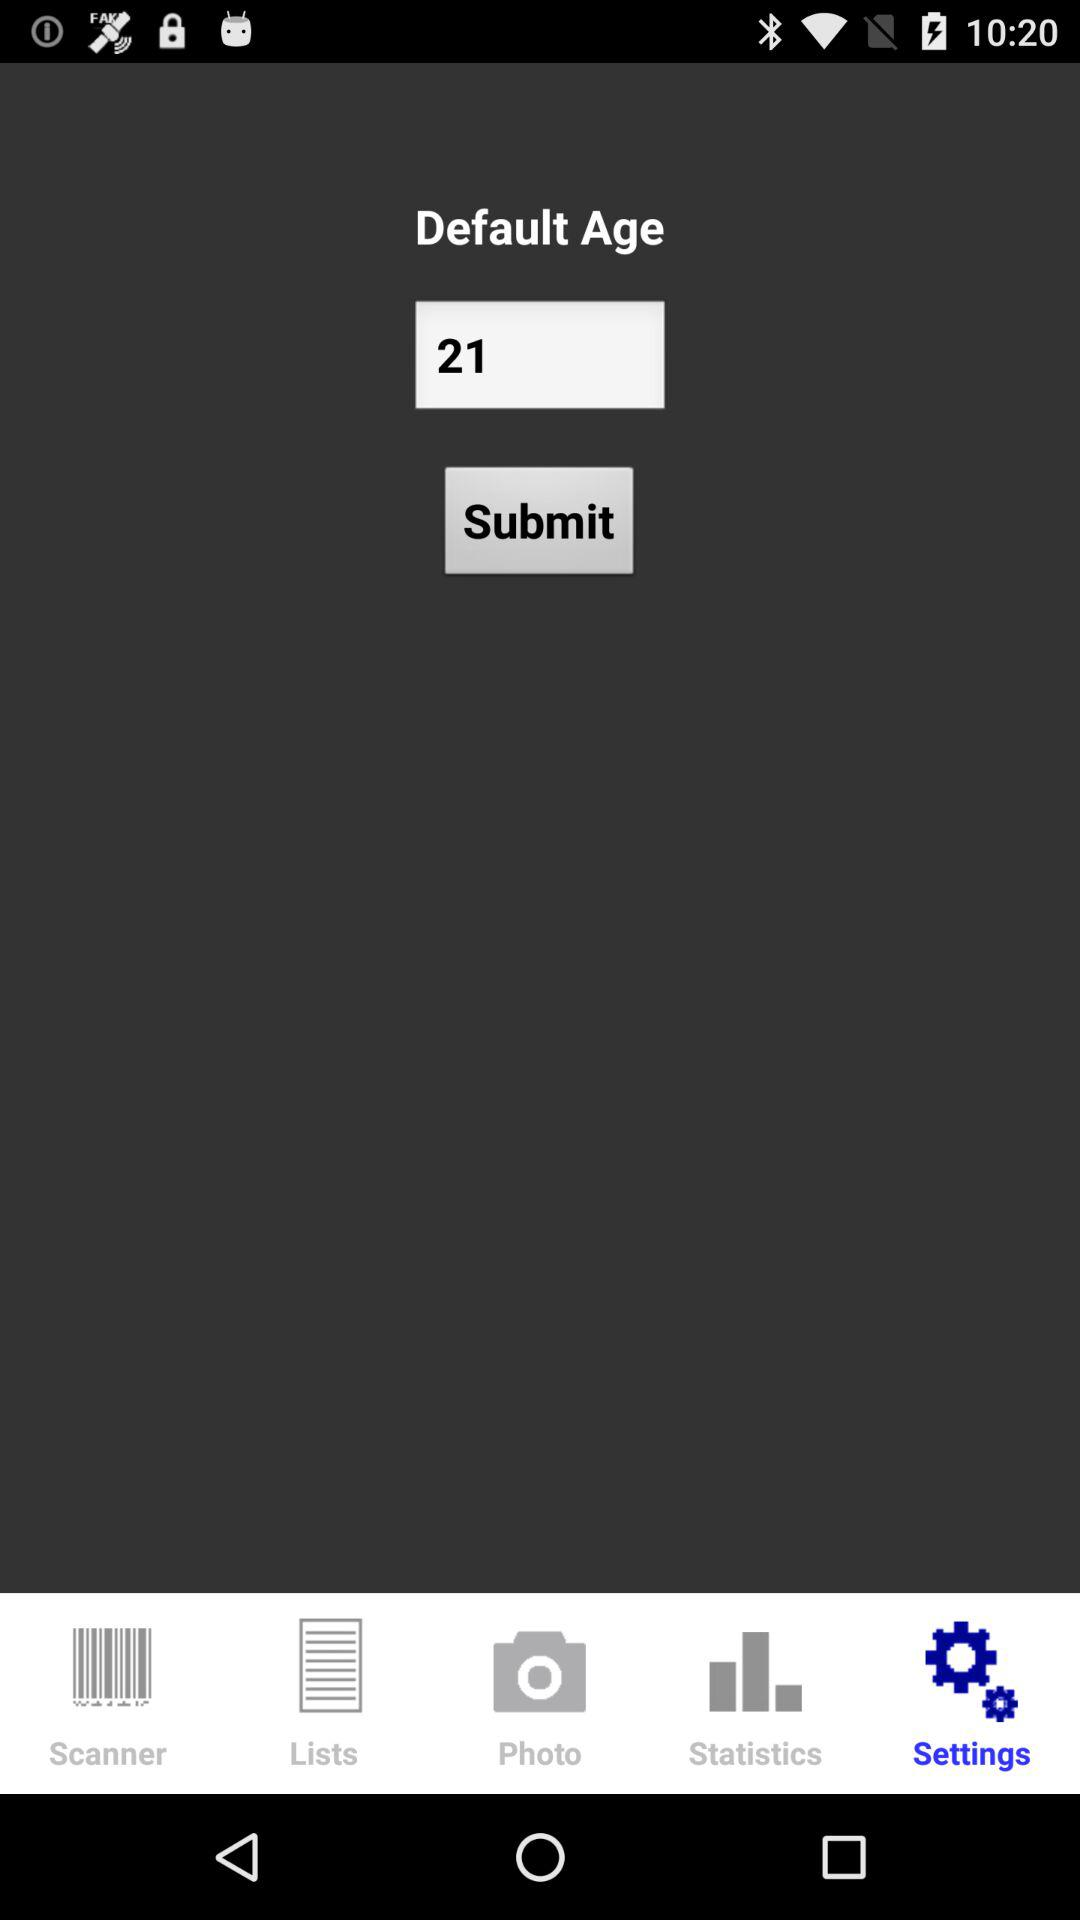What is the default age? The default age is 21. 